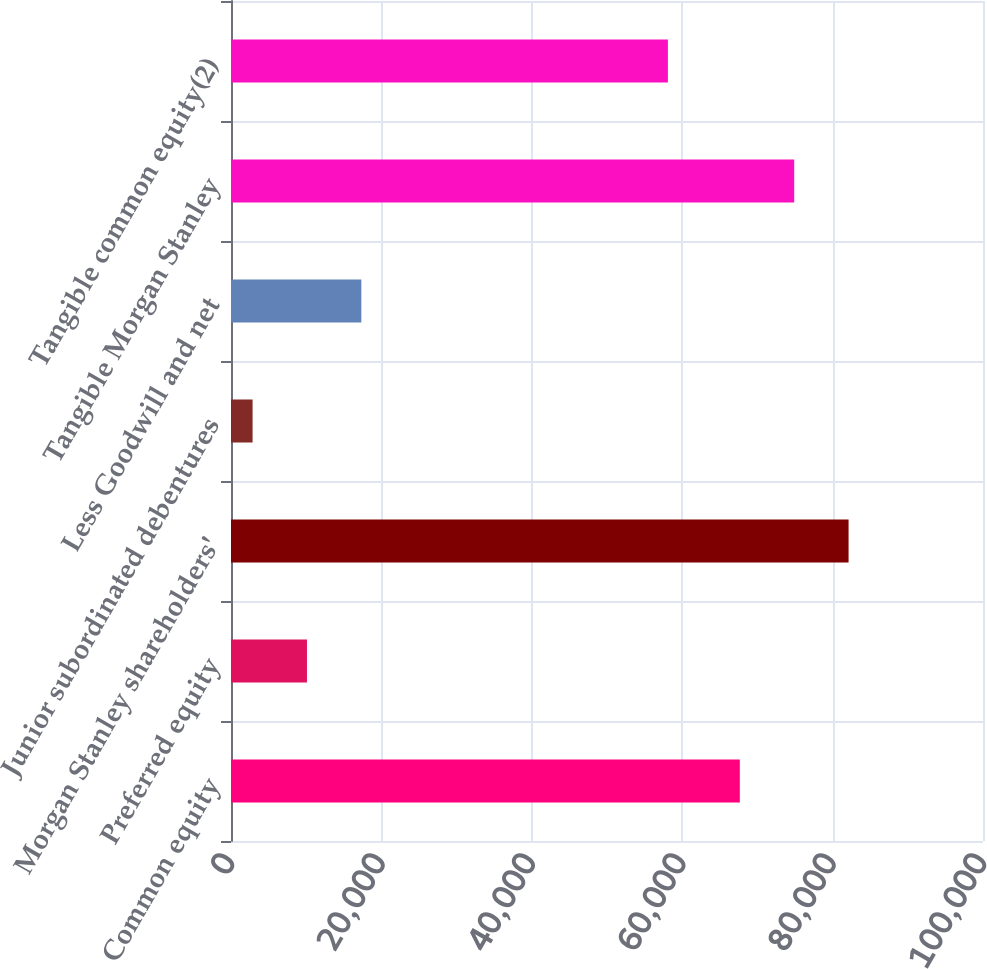Convert chart to OTSL. <chart><loc_0><loc_0><loc_500><loc_500><bar_chart><fcel>Common equity<fcel>Preferred equity<fcel>Morgan Stanley shareholders'<fcel>Junior subordinated debentures<fcel>Less Goodwill and net<fcel>Tangible Morgan Stanley<fcel>Tangible common equity(2)<nl><fcel>67662<fcel>10101.2<fcel>82124.4<fcel>2870<fcel>17332.4<fcel>74893.2<fcel>58098<nl></chart> 